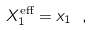<formula> <loc_0><loc_0><loc_500><loc_500>X _ { 1 } ^ { \text {eff} } = x _ { 1 } \ ,</formula> 